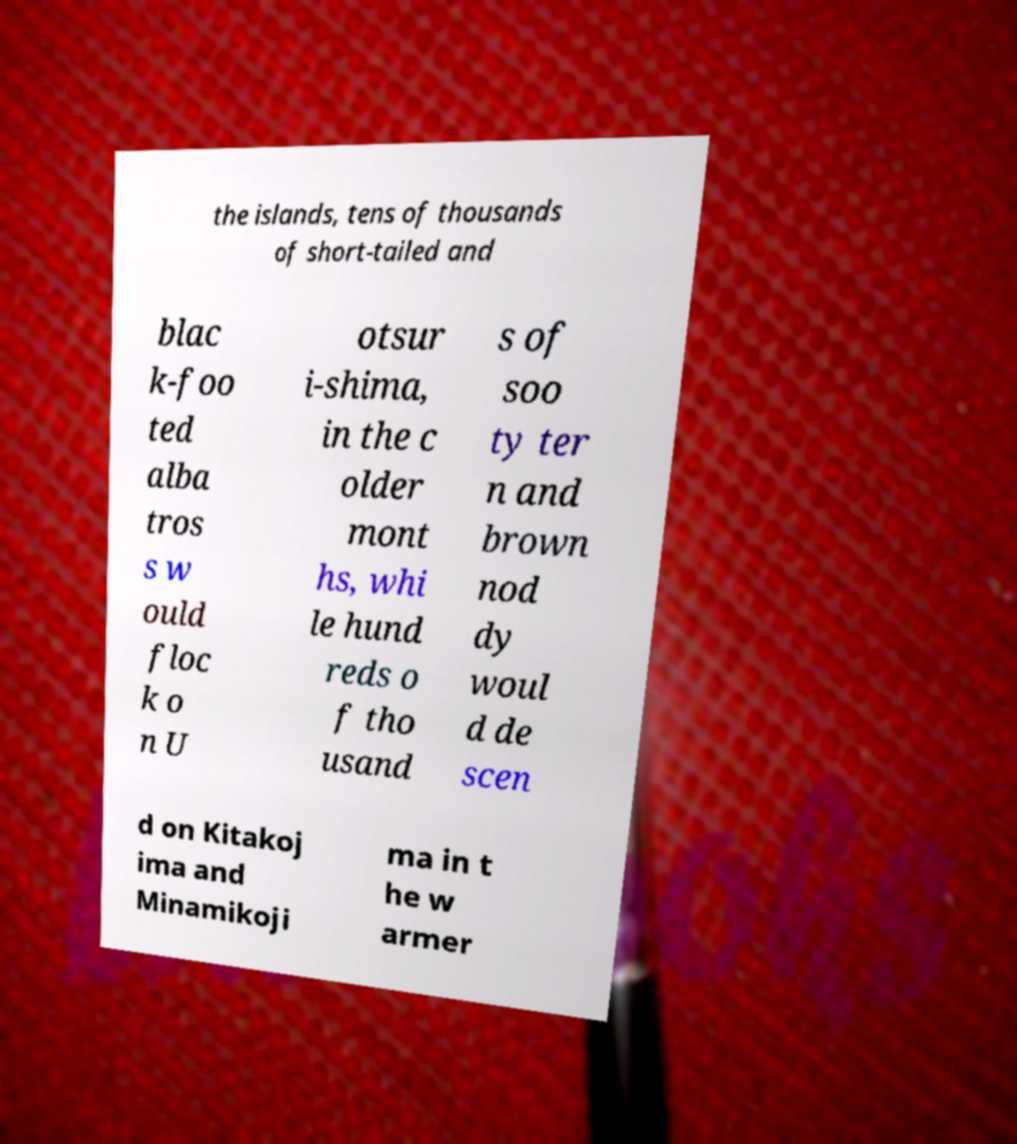Please identify and transcribe the text found in this image. the islands, tens of thousands of short-tailed and blac k-foo ted alba tros s w ould floc k o n U otsur i-shima, in the c older mont hs, whi le hund reds o f tho usand s of soo ty ter n and brown nod dy woul d de scen d on Kitakoj ima and Minamikoji ma in t he w armer 